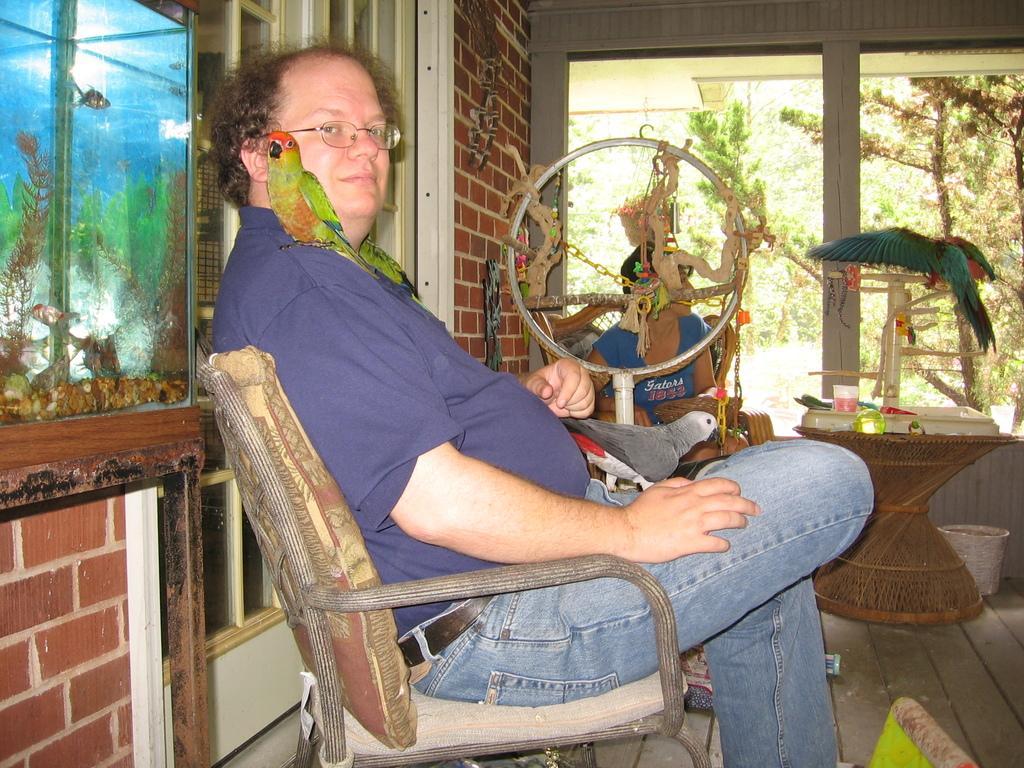Please provide a concise description of this image. In this image I see a man who is sitting on the chair and he is smiling and I can also see that there are 2 birds on him. In the background I see another person who is sitting on the chair and I see the bird over here and I see the windows, plants and a aquarium over here. 